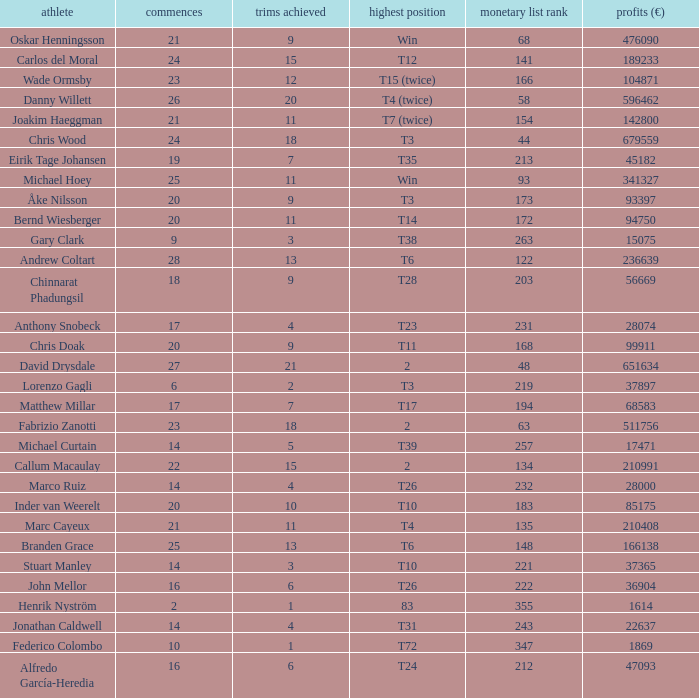What is the number of cuts made by bernd wiesberger? 11.0. 